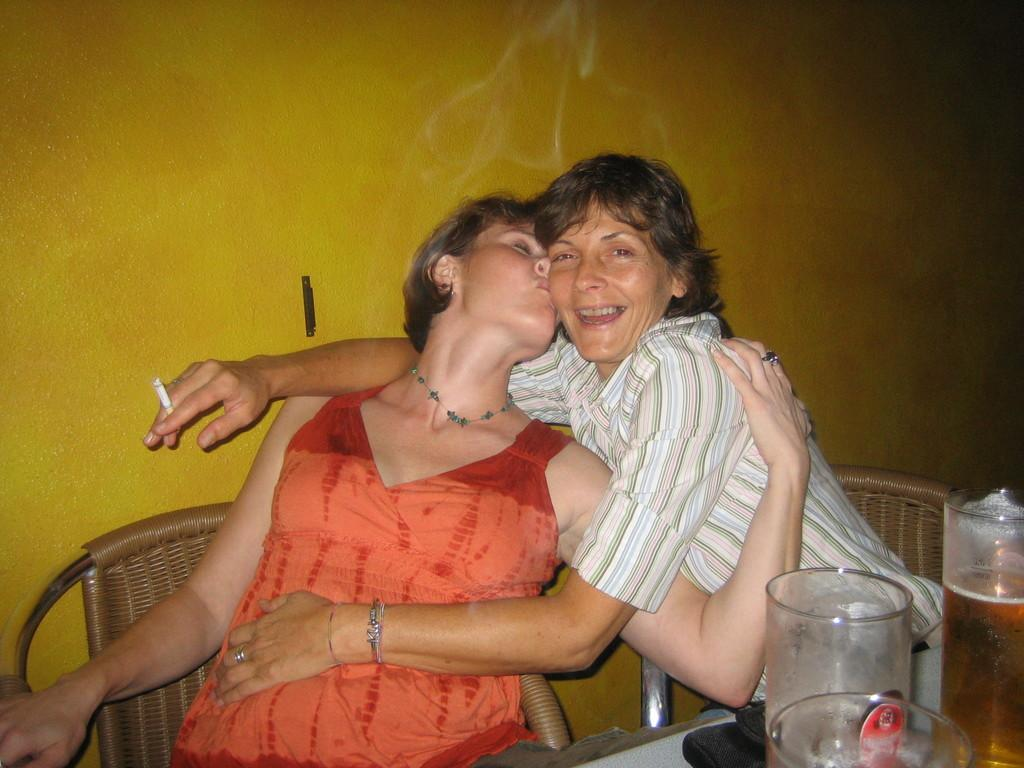What are the people in the image doing? The people in the image are sitting on chairs. What is on the table in the image? There are glasses on the table. What color is the black colored object in the image? The black colored object in the image is black. What can be seen behind the people in the image? There is a wall visible in the image. What type of meat is being served in the jail tent in the image? There is no jail or tent present in the image, and no meat is being served. 